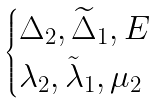Convert formula to latex. <formula><loc_0><loc_0><loc_500><loc_500>\begin{cases} \Delta _ { 2 } , \widetilde { \Delta } _ { 1 } , E \\ \lambda _ { 2 } , \tilde { \lambda } _ { 1 } , \mu _ { 2 } \end{cases}</formula> 